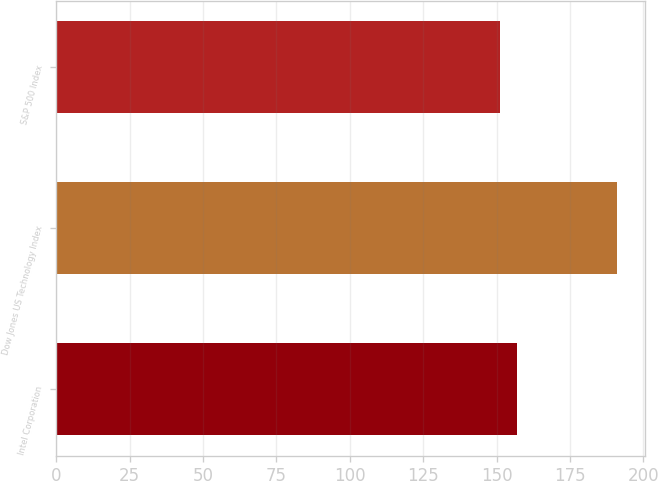<chart> <loc_0><loc_0><loc_500><loc_500><bar_chart><fcel>Intel Corporation<fcel>Dow Jones US Technology Index<fcel>S&P 500 Index<nl><fcel>157<fcel>191<fcel>151<nl></chart> 